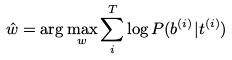<formula> <loc_0><loc_0><loc_500><loc_500>\hat { w } = \arg \max _ { w } \sum _ { i } ^ { T } \log P ( b ^ { ( i ) } | t ^ { ( i ) } )</formula> 